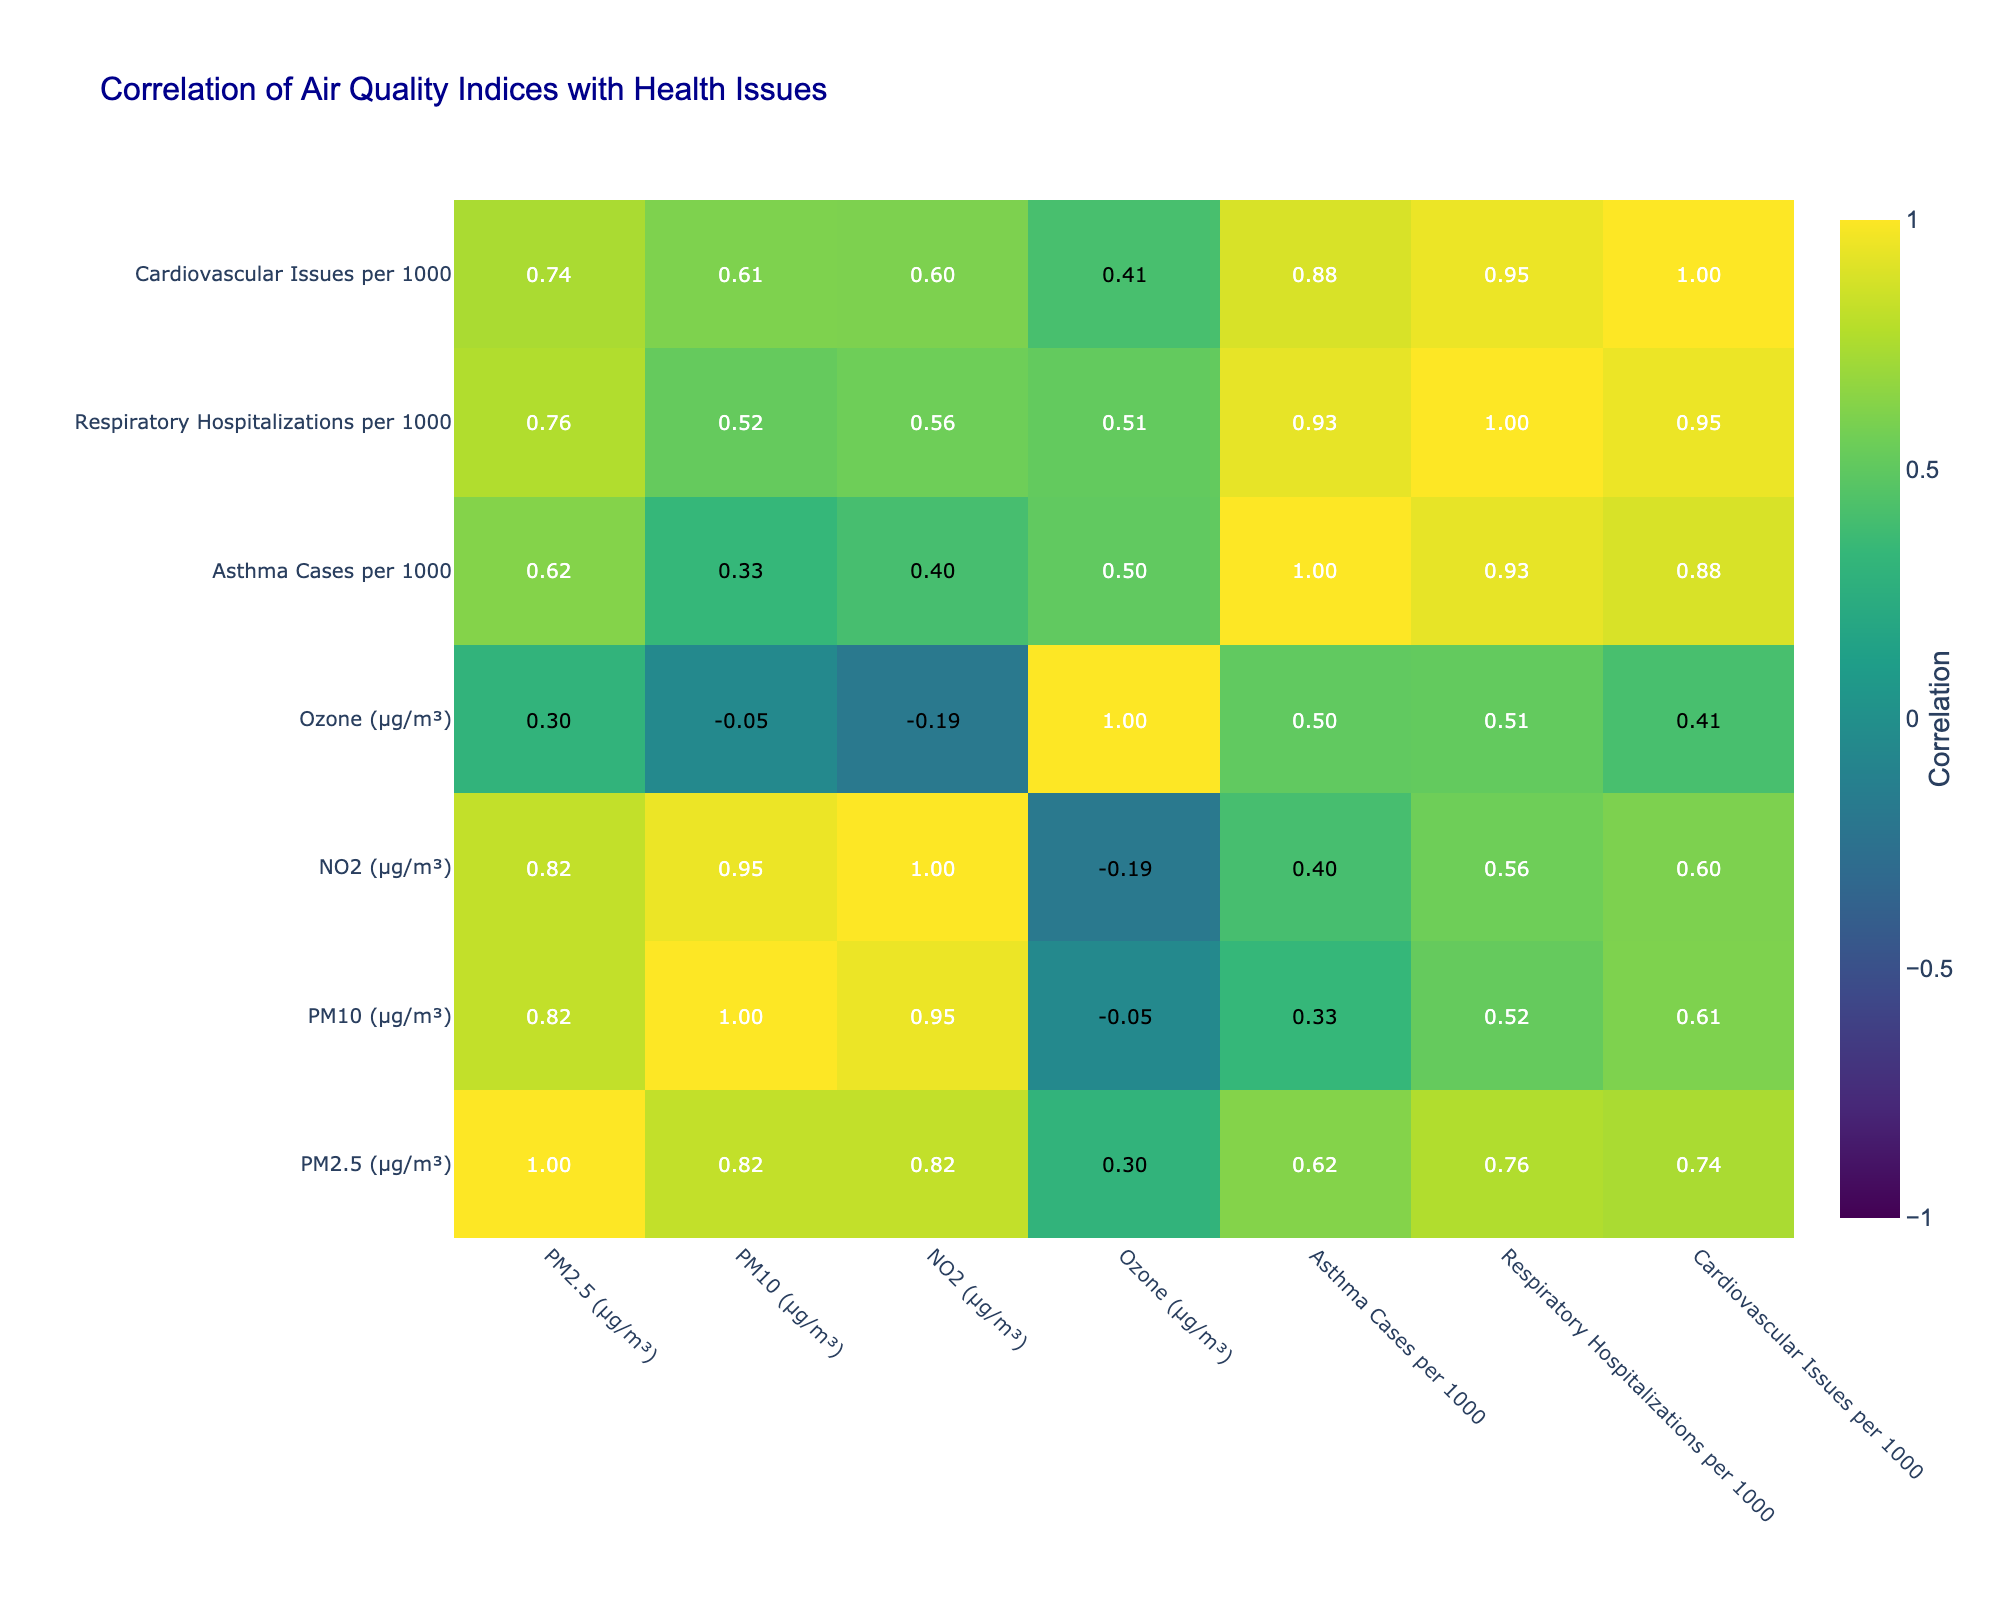What is the correlation between PM2.5 and asthma cases? In the correlation table, we check the value at the intersection of the PM2.5 row and the asthma cases column. The value is 0.84, indicating a strong positive correlation between PM2.5 and asthma cases.
Answer: 0.84 Which city has the highest PM10 levels? By looking at the PM10 column, we find that Manchester has the highest value of 42 µg/m³.
Answer: Manchester Is there a significant correlation between NO2 levels and cardiovascular issues? We examine the correlation between the NO2 row and the cardiovascular issues column, which shows a value of 0.79. This indicates a strong positive correlation, meaning that as NO2 levels increase, cardiovascular issues also tend to increase.
Answer: Yes What is the average rate of respiratory hospitalizations across all cities? To find the average, we sum all the values in the respiratory hospitalizations column (30 + 25 + 35 + 28 + 20 + 18 + 15 + 22 + 27 + 24 =  224) and divide by the number of cities (10): 224/10 = 22.4.
Answer: 22.4 Is asthma cases per 1000 directly related to ozone levels in all cities? By checking the correlation value between asthma cases and ozone, which is -0.02, we verify that there is no significant direct relationship. A value close to zero indicates little to no correlation.
Answer: No How many cities have respiratory hospitalizations below 20 per 1000? We review the respiratory hospitalizations column and find that both Liverpool (20) and Newcastle (15) have values less than or equal to 20. Therefore, 2 cities fit this criterion.
Answer: 2 What is the difference between the asthma cases per 1000 in London and in Leeds? We first locate the asthma cases for both cities, which are 50 for London and 35 for Leeds. We then subtract: 50 - 35 = 15.
Answer: 15 Which two cities exhibit the strongest correlation between PM10 and respiratory hospitalizations? We look at the PM10 row and the respiratory hospitalizations column to identify the values. The highest correlation coefficient is reached between Manchester (0.77) and Birmingham (0.69). Since their correlations are the highest for this pair, we conclude both cities exhibit strong correlations.
Answer: Manchester and Birmingham Is there a negative correlation between ozone levels and asthma cases? We check the correlation value between the ozone row and asthma cases column, which is -0.39. This indicates a moderate negative correlation, suggesting that higher ozone levels are associated with fewer asthma cases.
Answer: Yes 